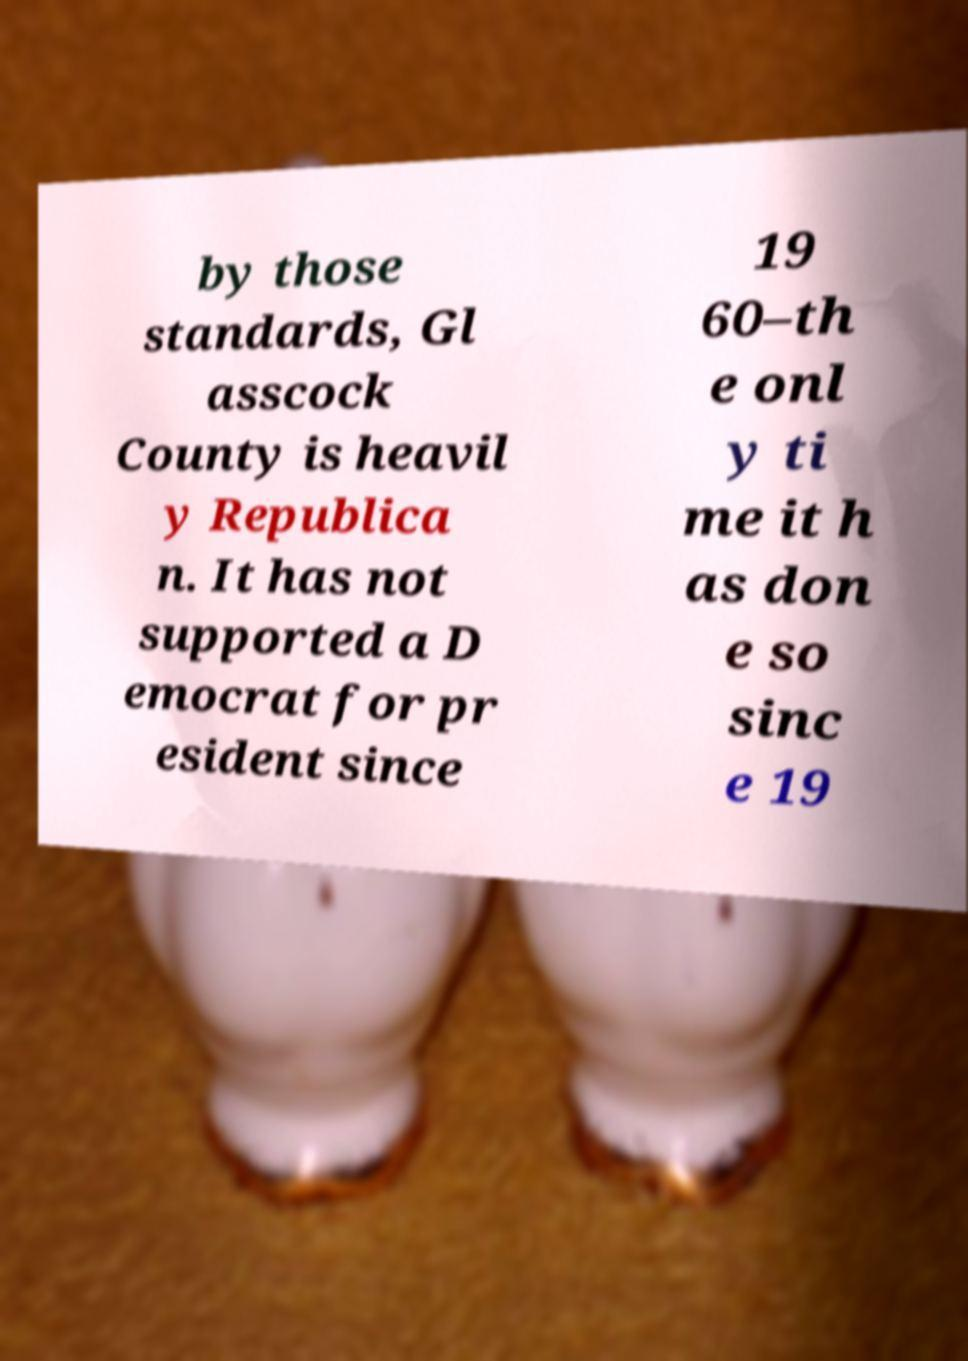For documentation purposes, I need the text within this image transcribed. Could you provide that? by those standards, Gl asscock County is heavil y Republica n. It has not supported a D emocrat for pr esident since 19 60–th e onl y ti me it h as don e so sinc e 19 